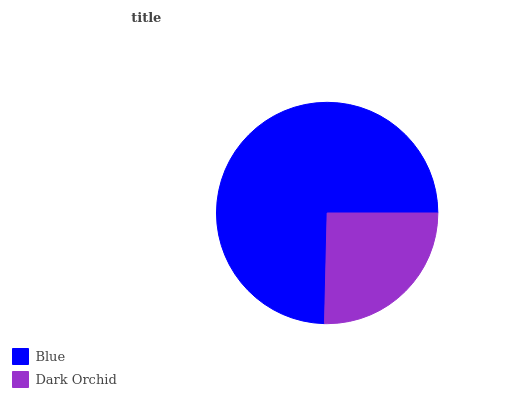Is Dark Orchid the minimum?
Answer yes or no. Yes. Is Blue the maximum?
Answer yes or no. Yes. Is Dark Orchid the maximum?
Answer yes or no. No. Is Blue greater than Dark Orchid?
Answer yes or no. Yes. Is Dark Orchid less than Blue?
Answer yes or no. Yes. Is Dark Orchid greater than Blue?
Answer yes or no. No. Is Blue less than Dark Orchid?
Answer yes or no. No. Is Blue the high median?
Answer yes or no. Yes. Is Dark Orchid the low median?
Answer yes or no. Yes. Is Dark Orchid the high median?
Answer yes or no. No. Is Blue the low median?
Answer yes or no. No. 